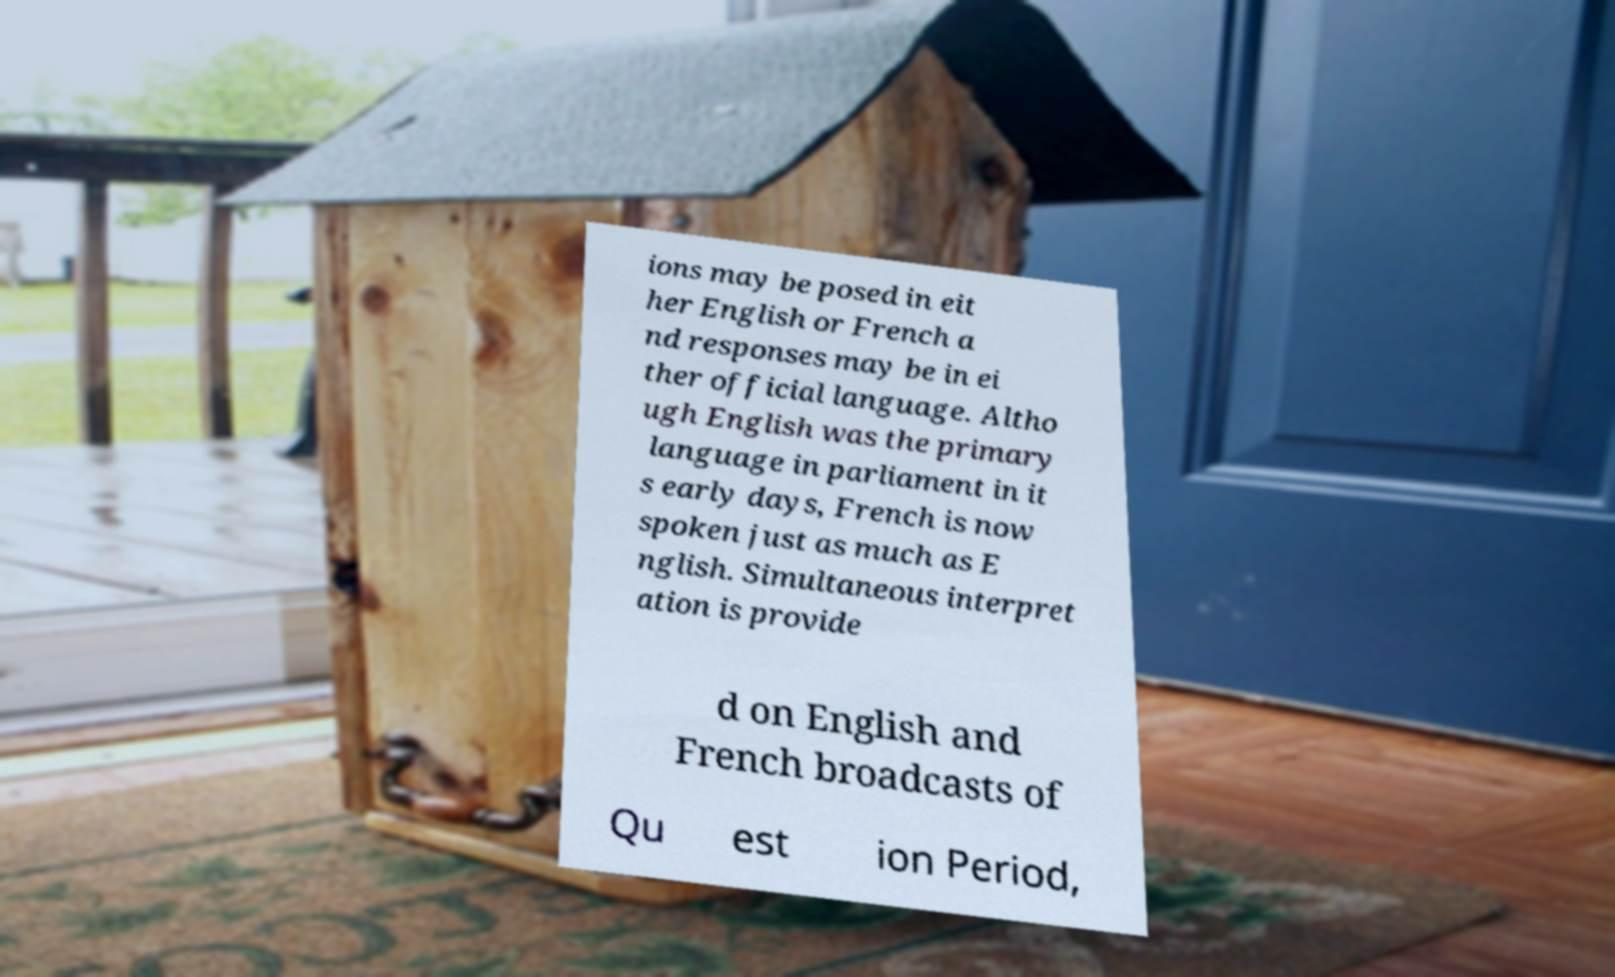Can you read and provide the text displayed in the image?This photo seems to have some interesting text. Can you extract and type it out for me? ions may be posed in eit her English or French a nd responses may be in ei ther official language. Altho ugh English was the primary language in parliament in it s early days, French is now spoken just as much as E nglish. Simultaneous interpret ation is provide d on English and French broadcasts of Qu est ion Period, 